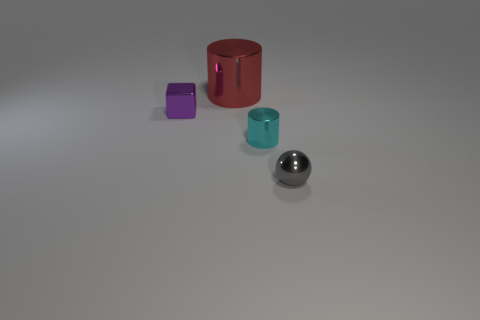What number of metal objects are either tiny cyan objects or gray things?
Your answer should be compact. 2. There is a object that is behind the gray ball and on the right side of the large red cylinder; what material is it made of?
Keep it short and to the point. Metal. Is there a big red cylinder in front of the tiny shiny object that is left of the shiny cylinder on the right side of the red metallic thing?
Keep it short and to the point. No. Is there anything else that is made of the same material as the red cylinder?
Offer a very short reply. Yes. What is the shape of the large red thing that is the same material as the cyan object?
Provide a short and direct response. Cylinder. Are there fewer small gray balls that are behind the purple metallic block than big cylinders that are behind the large cylinder?
Make the answer very short. No. What number of small things are either gray objects or cyan matte objects?
Give a very brief answer. 1. There is a red object behind the tiny cyan metal object; is it the same shape as the tiny cyan object to the right of the big red object?
Your response must be concise. Yes. How big is the metallic cylinder that is in front of the small object to the left of the shiny cylinder that is behind the cyan metal cylinder?
Your answer should be compact. Small. There is a cylinder that is behind the small cyan cylinder; what size is it?
Offer a terse response. Large. 